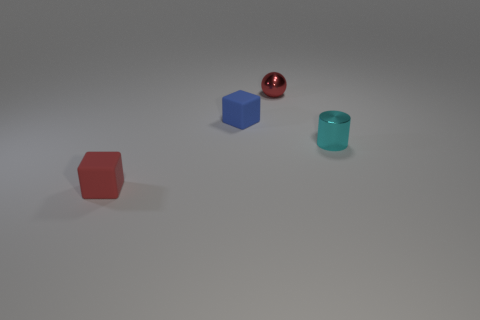How many other objects are the same color as the metal cylinder?
Your response must be concise. 0. How big is the red thing that is right of the tiny block behind the red rubber object?
Provide a succinct answer. Small. Are the cube that is in front of the cyan shiny cylinder and the small object that is to the right of the small red shiny sphere made of the same material?
Offer a very short reply. No. Do the thing to the left of the blue block and the ball have the same color?
Provide a succinct answer. Yes. There is a cyan cylinder; what number of blocks are behind it?
Provide a short and direct response. 1. Is the material of the cyan object the same as the red object that is behind the red matte block?
Provide a succinct answer. Yes. There is a red sphere that is made of the same material as the cyan cylinder; what is its size?
Provide a short and direct response. Small. Are there more tiny balls that are behind the small cyan cylinder than tiny cubes that are behind the blue matte cube?
Ensure brevity in your answer.  Yes. Is there another object that has the same shape as the blue rubber thing?
Your answer should be compact. Yes. There is a object left of the blue block; does it have the same size as the small blue rubber thing?
Make the answer very short. Yes. 